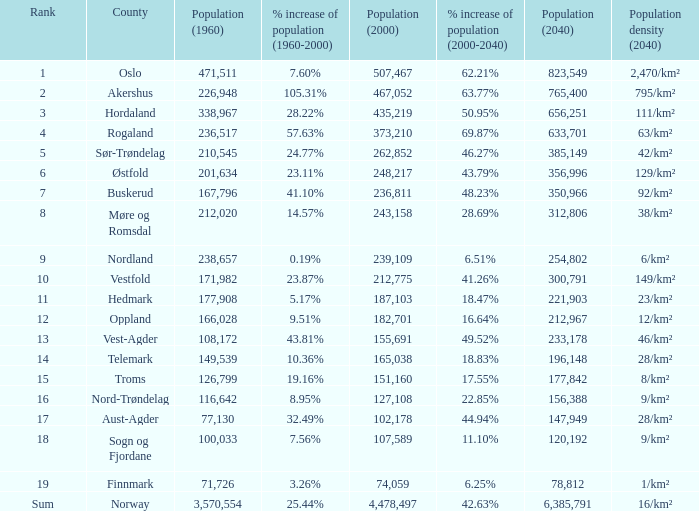What was the population of a county in 1960 that had a population of 467,052 in 2000 and 78,812 in 2040? None. 